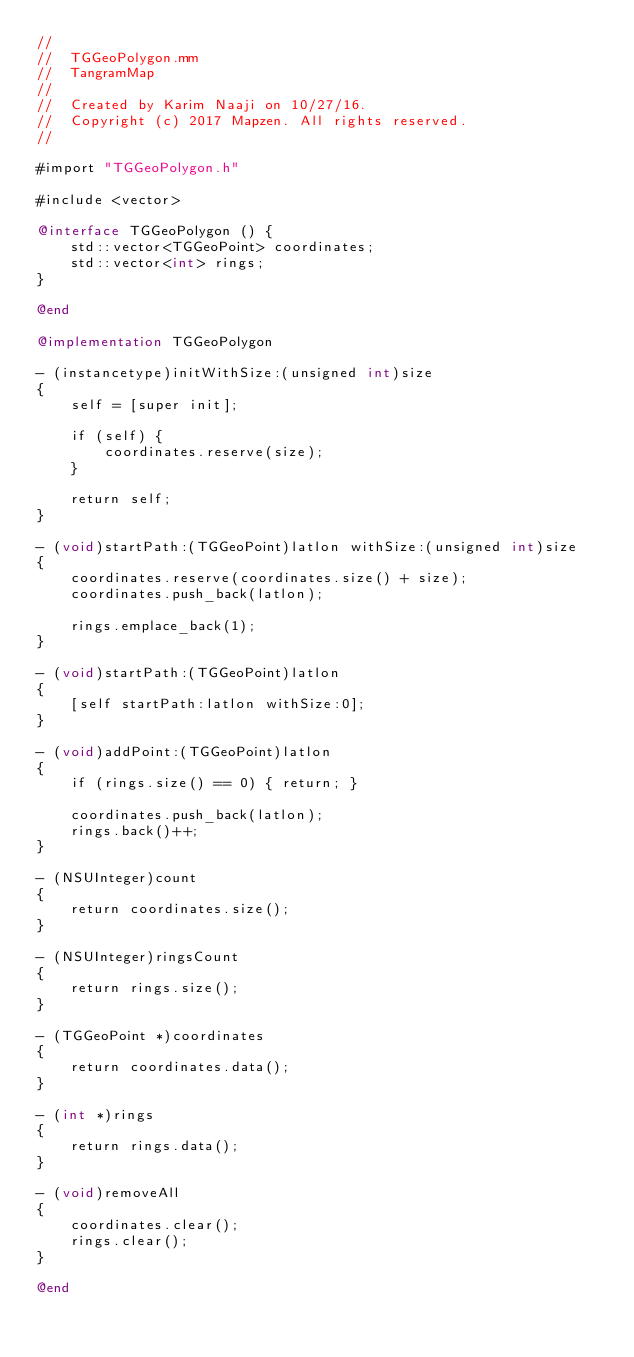<code> <loc_0><loc_0><loc_500><loc_500><_ObjectiveC_>//
//  TGGeoPolygon.mm
//  TangramMap
//
//  Created by Karim Naaji on 10/27/16.
//  Copyright (c) 2017 Mapzen. All rights reserved.
//

#import "TGGeoPolygon.h"

#include <vector>

@interface TGGeoPolygon () {
    std::vector<TGGeoPoint> coordinates;
    std::vector<int> rings;
}

@end

@implementation TGGeoPolygon

- (instancetype)initWithSize:(unsigned int)size
{
    self = [super init];

    if (self) {
        coordinates.reserve(size);
    }

    return self;
}

- (void)startPath:(TGGeoPoint)latlon withSize:(unsigned int)size
{
    coordinates.reserve(coordinates.size() + size);
    coordinates.push_back(latlon);

    rings.emplace_back(1);
}

- (void)startPath:(TGGeoPoint)latlon
{
    [self startPath:latlon withSize:0];
}

- (void)addPoint:(TGGeoPoint)latlon
{
    if (rings.size() == 0) { return; }

    coordinates.push_back(latlon);
    rings.back()++;
}

- (NSUInteger)count
{
    return coordinates.size();
}

- (NSUInteger)ringsCount
{
    return rings.size();
}

- (TGGeoPoint *)coordinates
{
    return coordinates.data();
}

- (int *)rings
{
    return rings.data();
}

- (void)removeAll
{
    coordinates.clear();
    rings.clear();
}

@end
</code> 